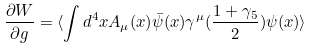Convert formula to latex. <formula><loc_0><loc_0><loc_500><loc_500>\frac { \partial W } { \partial g } = \langle \int d ^ { 4 } x A _ { \mu } ( x ) \bar { \psi } ( x ) \gamma ^ { \mu } ( \frac { 1 + \gamma _ { 5 } } { 2 } ) \psi ( x ) \rangle</formula> 